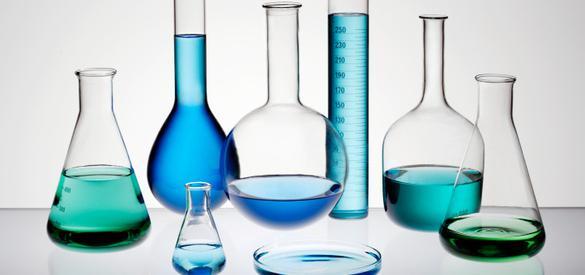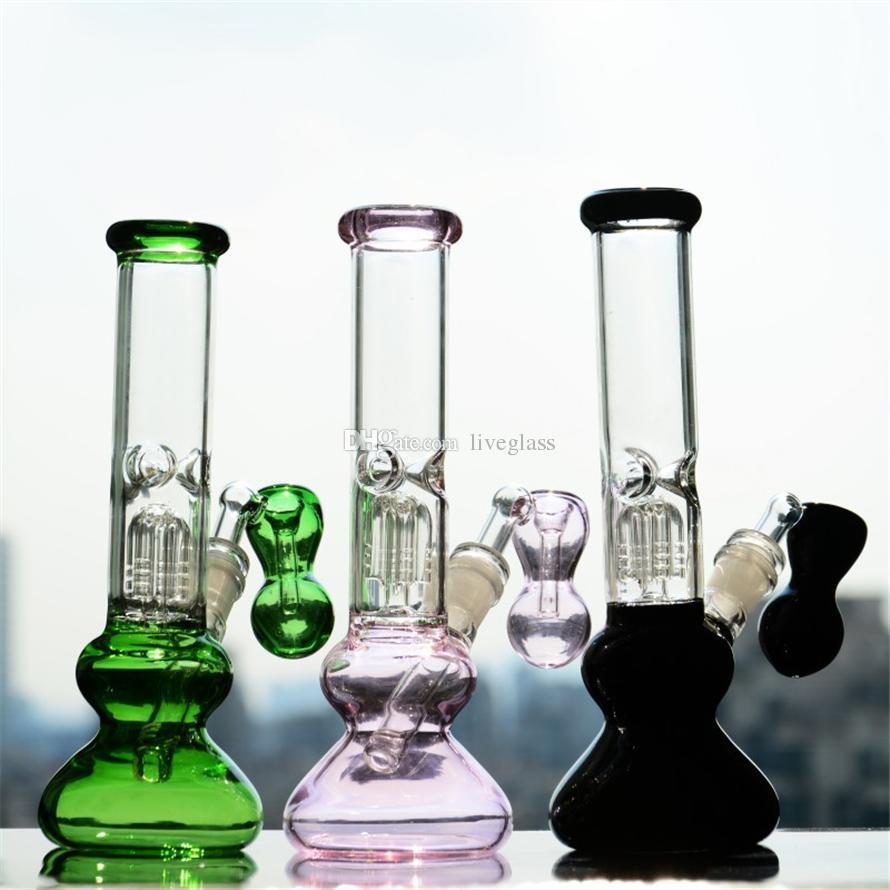The first image is the image on the left, the second image is the image on the right. Evaluate the accuracy of this statement regarding the images: "There is at least one beaker looking bong in the image.". Is it true? Answer yes or no. Yes. 